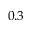Convert formula to latex. <formula><loc_0><loc_0><loc_500><loc_500>0 . 3</formula> 